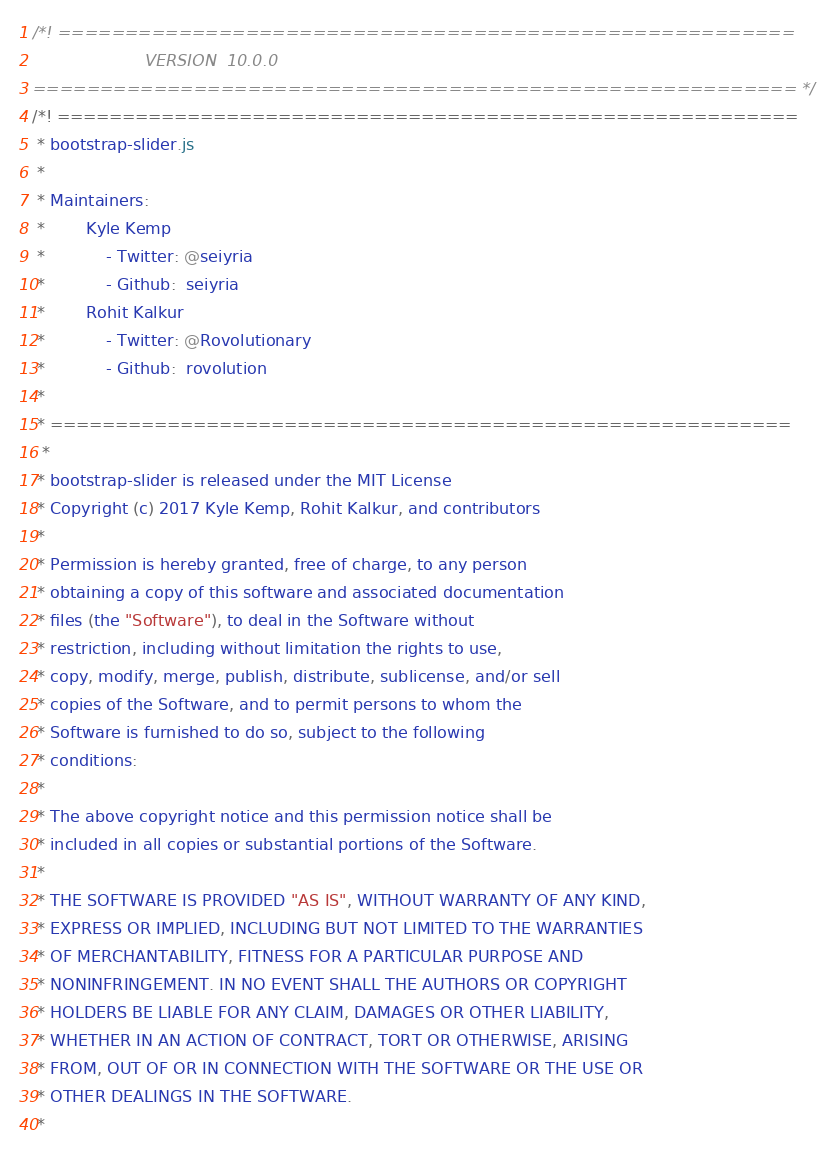Convert code to text. <code><loc_0><loc_0><loc_500><loc_500><_CSS_>/*! =======================================================
                      VERSION  10.0.0              
========================================================= */
/*! =========================================================
 * bootstrap-slider.js
 *
 * Maintainers:
 *		Kyle Kemp
 *			- Twitter: @seiyria
 *			- Github:  seiyria
 *		Rohit Kalkur
 *			- Twitter: @Rovolutionary
 *			- Github:  rovolution
 *
 * =========================================================
  *
 * bootstrap-slider is released under the MIT License
 * Copyright (c) 2017 Kyle Kemp, Rohit Kalkur, and contributors
 * 
 * Permission is hereby granted, free of charge, to any person
 * obtaining a copy of this software and associated documentation
 * files (the "Software"), to deal in the Software without
 * restriction, including without limitation the rights to use,
 * copy, modify, merge, publish, distribute, sublicense, and/or sell
 * copies of the Software, and to permit persons to whom the
 * Software is furnished to do so, subject to the following
 * conditions:
 * 
 * The above copyright notice and this permission notice shall be
 * included in all copies or substantial portions of the Software.
 * 
 * THE SOFTWARE IS PROVIDED "AS IS", WITHOUT WARRANTY OF ANY KIND,
 * EXPRESS OR IMPLIED, INCLUDING BUT NOT LIMITED TO THE WARRANTIES
 * OF MERCHANTABILITY, FITNESS FOR A PARTICULAR PURPOSE AND
 * NONINFRINGEMENT. IN NO EVENT SHALL THE AUTHORS OR COPYRIGHT
 * HOLDERS BE LIABLE FOR ANY CLAIM, DAMAGES OR OTHER LIABILITY,
 * WHETHER IN AN ACTION OF CONTRACT, TORT OR OTHERWISE, ARISING
 * FROM, OUT OF OR IN CONNECTION WITH THE SOFTWARE OR THE USE OR
 * OTHER DEALINGS IN THE SOFTWARE.
 *</code> 